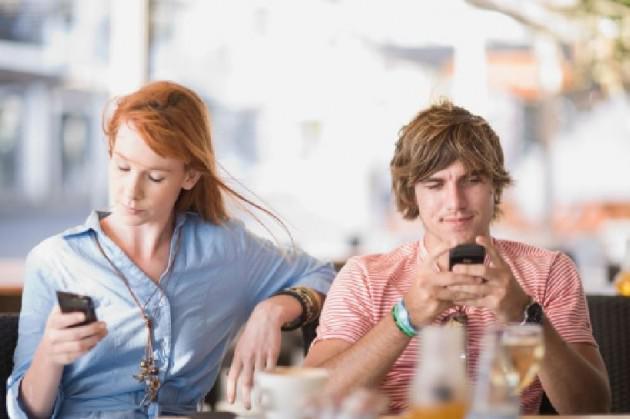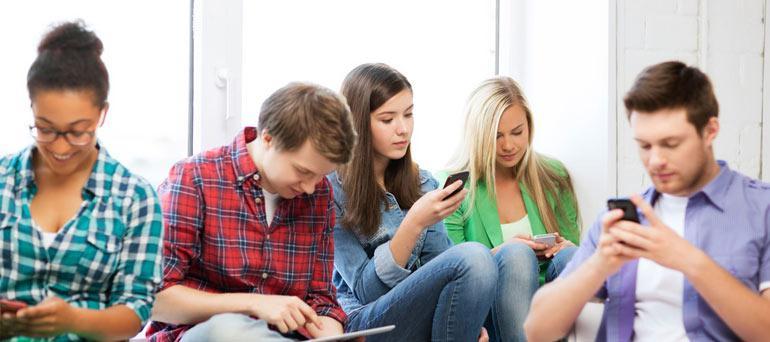The first image is the image on the left, the second image is the image on the right. Given the left and right images, does the statement "Three people are sitting together looking at their phones in the image on the right." hold true? Answer yes or no. No. The first image is the image on the left, the second image is the image on the right. Given the left and right images, does the statement "there are three people sitting at a shiny brown table looking at their phones, there are two men on the outside and a woman in the center" hold true? Answer yes or no. No. 